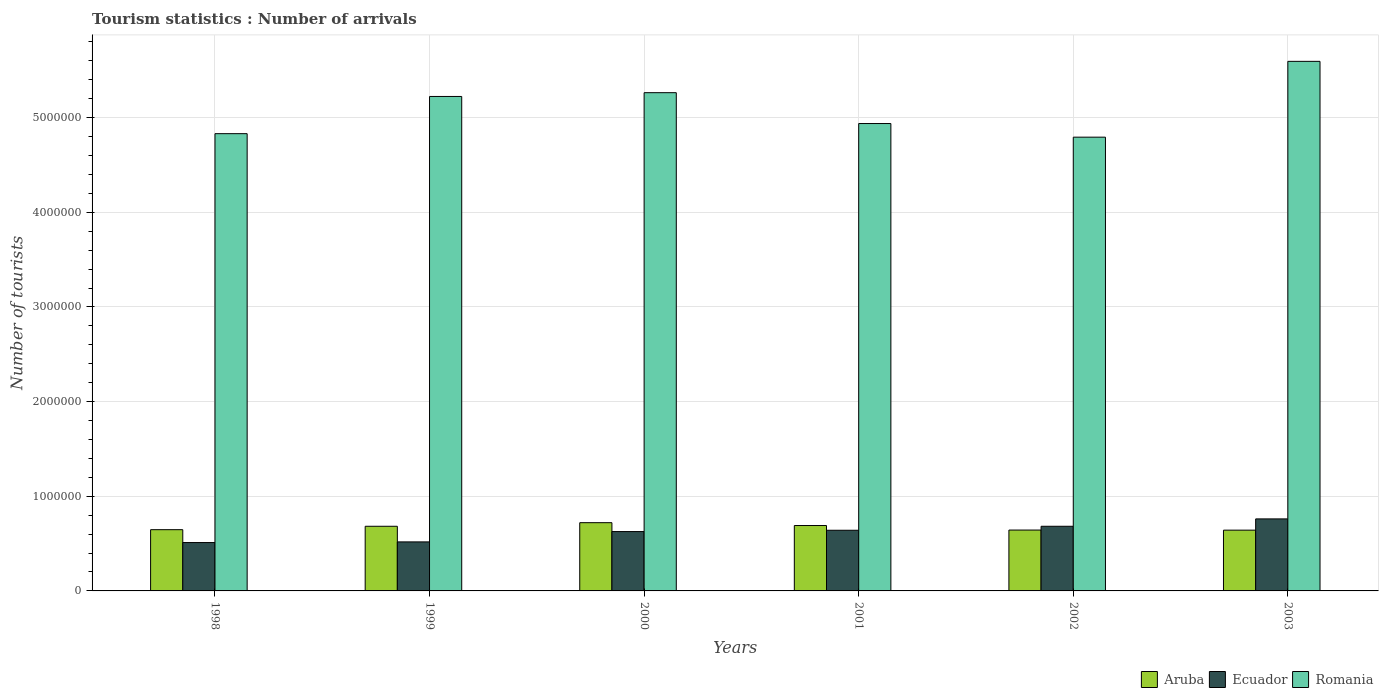Are the number of bars on each tick of the X-axis equal?
Your answer should be compact. Yes. How many bars are there on the 2nd tick from the left?
Provide a succinct answer. 3. How many bars are there on the 3rd tick from the right?
Your response must be concise. 3. What is the label of the 3rd group of bars from the left?
Your answer should be very brief. 2000. What is the number of tourist arrivals in Romania in 2000?
Your answer should be compact. 5.26e+06. Across all years, what is the maximum number of tourist arrivals in Ecuador?
Give a very brief answer. 7.61e+05. Across all years, what is the minimum number of tourist arrivals in Aruba?
Ensure brevity in your answer.  6.42e+05. In which year was the number of tourist arrivals in Romania maximum?
Offer a very short reply. 2003. In which year was the number of tourist arrivals in Romania minimum?
Give a very brief answer. 2002. What is the total number of tourist arrivals in Aruba in the graph?
Your answer should be very brief. 4.03e+06. What is the difference between the number of tourist arrivals in Romania in 2000 and that in 2002?
Keep it short and to the point. 4.70e+05. What is the difference between the number of tourist arrivals in Aruba in 2003 and the number of tourist arrivals in Romania in 2001?
Offer a very short reply. -4.30e+06. What is the average number of tourist arrivals in Ecuador per year?
Give a very brief answer. 6.24e+05. In the year 2000, what is the difference between the number of tourist arrivals in Romania and number of tourist arrivals in Ecuador?
Offer a terse response. 4.64e+06. What is the ratio of the number of tourist arrivals in Romania in 1998 to that in 2000?
Offer a very short reply. 0.92. Is the number of tourist arrivals in Romania in 1999 less than that in 2001?
Your answer should be very brief. No. What is the difference between the highest and the second highest number of tourist arrivals in Romania?
Keep it short and to the point. 3.31e+05. What is the difference between the highest and the lowest number of tourist arrivals in Aruba?
Ensure brevity in your answer.  7.90e+04. What does the 2nd bar from the left in 1998 represents?
Your answer should be very brief. Ecuador. What does the 3rd bar from the right in 2001 represents?
Your answer should be compact. Aruba. Is it the case that in every year, the sum of the number of tourist arrivals in Aruba and number of tourist arrivals in Ecuador is greater than the number of tourist arrivals in Romania?
Provide a succinct answer. No. Are all the bars in the graph horizontal?
Offer a terse response. No. What is the difference between two consecutive major ticks on the Y-axis?
Keep it short and to the point. 1.00e+06. Are the values on the major ticks of Y-axis written in scientific E-notation?
Your answer should be very brief. No. Does the graph contain grids?
Your answer should be compact. Yes. Where does the legend appear in the graph?
Your answer should be compact. Bottom right. How many legend labels are there?
Offer a very short reply. 3. What is the title of the graph?
Make the answer very short. Tourism statistics : Number of arrivals. Does "Botswana" appear as one of the legend labels in the graph?
Make the answer very short. No. What is the label or title of the X-axis?
Your answer should be compact. Years. What is the label or title of the Y-axis?
Your answer should be very brief. Number of tourists. What is the Number of tourists of Aruba in 1998?
Your response must be concise. 6.47e+05. What is the Number of tourists in Ecuador in 1998?
Your response must be concise. 5.11e+05. What is the Number of tourists in Romania in 1998?
Your answer should be very brief. 4.83e+06. What is the Number of tourists in Aruba in 1999?
Your answer should be very brief. 6.83e+05. What is the Number of tourists of Ecuador in 1999?
Offer a very short reply. 5.18e+05. What is the Number of tourists in Romania in 1999?
Make the answer very short. 5.22e+06. What is the Number of tourists of Aruba in 2000?
Make the answer very short. 7.21e+05. What is the Number of tourists of Ecuador in 2000?
Your answer should be compact. 6.27e+05. What is the Number of tourists of Romania in 2000?
Make the answer very short. 5.26e+06. What is the Number of tourists in Aruba in 2001?
Provide a short and direct response. 6.91e+05. What is the Number of tourists in Ecuador in 2001?
Make the answer very short. 6.41e+05. What is the Number of tourists in Romania in 2001?
Your answer should be compact. 4.94e+06. What is the Number of tourists in Aruba in 2002?
Give a very brief answer. 6.43e+05. What is the Number of tourists in Ecuador in 2002?
Your answer should be compact. 6.83e+05. What is the Number of tourists in Romania in 2002?
Your answer should be very brief. 4.79e+06. What is the Number of tourists of Aruba in 2003?
Make the answer very short. 6.42e+05. What is the Number of tourists of Ecuador in 2003?
Offer a terse response. 7.61e+05. What is the Number of tourists of Romania in 2003?
Give a very brief answer. 5.60e+06. Across all years, what is the maximum Number of tourists in Aruba?
Offer a terse response. 7.21e+05. Across all years, what is the maximum Number of tourists of Ecuador?
Offer a terse response. 7.61e+05. Across all years, what is the maximum Number of tourists in Romania?
Make the answer very short. 5.60e+06. Across all years, what is the minimum Number of tourists of Aruba?
Offer a very short reply. 6.42e+05. Across all years, what is the minimum Number of tourists in Ecuador?
Provide a succinct answer. 5.11e+05. Across all years, what is the minimum Number of tourists of Romania?
Your answer should be compact. 4.79e+06. What is the total Number of tourists in Aruba in the graph?
Give a very brief answer. 4.03e+06. What is the total Number of tourists of Ecuador in the graph?
Make the answer very short. 3.74e+06. What is the total Number of tourists of Romania in the graph?
Give a very brief answer. 3.06e+07. What is the difference between the Number of tourists in Aruba in 1998 and that in 1999?
Offer a very short reply. -3.60e+04. What is the difference between the Number of tourists in Ecuador in 1998 and that in 1999?
Keep it short and to the point. -7000. What is the difference between the Number of tourists in Romania in 1998 and that in 1999?
Offer a terse response. -3.93e+05. What is the difference between the Number of tourists of Aruba in 1998 and that in 2000?
Make the answer very short. -7.40e+04. What is the difference between the Number of tourists in Ecuador in 1998 and that in 2000?
Keep it short and to the point. -1.16e+05. What is the difference between the Number of tourists of Romania in 1998 and that in 2000?
Keep it short and to the point. -4.33e+05. What is the difference between the Number of tourists in Aruba in 1998 and that in 2001?
Ensure brevity in your answer.  -4.40e+04. What is the difference between the Number of tourists of Ecuador in 1998 and that in 2001?
Your response must be concise. -1.30e+05. What is the difference between the Number of tourists of Romania in 1998 and that in 2001?
Ensure brevity in your answer.  -1.07e+05. What is the difference between the Number of tourists of Aruba in 1998 and that in 2002?
Keep it short and to the point. 4000. What is the difference between the Number of tourists in Ecuador in 1998 and that in 2002?
Your answer should be very brief. -1.72e+05. What is the difference between the Number of tourists of Romania in 1998 and that in 2002?
Make the answer very short. 3.70e+04. What is the difference between the Number of tourists in Aruba in 1998 and that in 2003?
Make the answer very short. 5000. What is the difference between the Number of tourists of Romania in 1998 and that in 2003?
Provide a short and direct response. -7.64e+05. What is the difference between the Number of tourists in Aruba in 1999 and that in 2000?
Your answer should be compact. -3.80e+04. What is the difference between the Number of tourists in Ecuador in 1999 and that in 2000?
Offer a very short reply. -1.09e+05. What is the difference between the Number of tourists in Romania in 1999 and that in 2000?
Make the answer very short. -4.00e+04. What is the difference between the Number of tourists of Aruba in 1999 and that in 2001?
Provide a succinct answer. -8000. What is the difference between the Number of tourists in Ecuador in 1999 and that in 2001?
Ensure brevity in your answer.  -1.23e+05. What is the difference between the Number of tourists in Romania in 1999 and that in 2001?
Your response must be concise. 2.86e+05. What is the difference between the Number of tourists in Aruba in 1999 and that in 2002?
Give a very brief answer. 4.00e+04. What is the difference between the Number of tourists of Ecuador in 1999 and that in 2002?
Keep it short and to the point. -1.65e+05. What is the difference between the Number of tourists of Aruba in 1999 and that in 2003?
Your answer should be compact. 4.10e+04. What is the difference between the Number of tourists in Ecuador in 1999 and that in 2003?
Offer a very short reply. -2.43e+05. What is the difference between the Number of tourists in Romania in 1999 and that in 2003?
Keep it short and to the point. -3.71e+05. What is the difference between the Number of tourists in Aruba in 2000 and that in 2001?
Keep it short and to the point. 3.00e+04. What is the difference between the Number of tourists of Ecuador in 2000 and that in 2001?
Give a very brief answer. -1.40e+04. What is the difference between the Number of tourists in Romania in 2000 and that in 2001?
Give a very brief answer. 3.26e+05. What is the difference between the Number of tourists of Aruba in 2000 and that in 2002?
Keep it short and to the point. 7.80e+04. What is the difference between the Number of tourists in Ecuador in 2000 and that in 2002?
Provide a short and direct response. -5.60e+04. What is the difference between the Number of tourists in Aruba in 2000 and that in 2003?
Offer a very short reply. 7.90e+04. What is the difference between the Number of tourists of Ecuador in 2000 and that in 2003?
Your response must be concise. -1.34e+05. What is the difference between the Number of tourists in Romania in 2000 and that in 2003?
Your answer should be very brief. -3.31e+05. What is the difference between the Number of tourists in Aruba in 2001 and that in 2002?
Give a very brief answer. 4.80e+04. What is the difference between the Number of tourists of Ecuador in 2001 and that in 2002?
Your answer should be very brief. -4.20e+04. What is the difference between the Number of tourists of Romania in 2001 and that in 2002?
Your answer should be compact. 1.44e+05. What is the difference between the Number of tourists in Aruba in 2001 and that in 2003?
Give a very brief answer. 4.90e+04. What is the difference between the Number of tourists in Ecuador in 2001 and that in 2003?
Give a very brief answer. -1.20e+05. What is the difference between the Number of tourists of Romania in 2001 and that in 2003?
Give a very brief answer. -6.57e+05. What is the difference between the Number of tourists of Aruba in 2002 and that in 2003?
Your answer should be very brief. 1000. What is the difference between the Number of tourists of Ecuador in 2002 and that in 2003?
Provide a short and direct response. -7.80e+04. What is the difference between the Number of tourists of Romania in 2002 and that in 2003?
Offer a terse response. -8.01e+05. What is the difference between the Number of tourists of Aruba in 1998 and the Number of tourists of Ecuador in 1999?
Provide a short and direct response. 1.29e+05. What is the difference between the Number of tourists in Aruba in 1998 and the Number of tourists in Romania in 1999?
Offer a very short reply. -4.58e+06. What is the difference between the Number of tourists in Ecuador in 1998 and the Number of tourists in Romania in 1999?
Ensure brevity in your answer.  -4.71e+06. What is the difference between the Number of tourists of Aruba in 1998 and the Number of tourists of Romania in 2000?
Your response must be concise. -4.62e+06. What is the difference between the Number of tourists in Ecuador in 1998 and the Number of tourists in Romania in 2000?
Ensure brevity in your answer.  -4.75e+06. What is the difference between the Number of tourists in Aruba in 1998 and the Number of tourists in Ecuador in 2001?
Offer a very short reply. 6000. What is the difference between the Number of tourists in Aruba in 1998 and the Number of tourists in Romania in 2001?
Ensure brevity in your answer.  -4.29e+06. What is the difference between the Number of tourists of Ecuador in 1998 and the Number of tourists of Romania in 2001?
Make the answer very short. -4.43e+06. What is the difference between the Number of tourists of Aruba in 1998 and the Number of tourists of Ecuador in 2002?
Give a very brief answer. -3.60e+04. What is the difference between the Number of tourists of Aruba in 1998 and the Number of tourists of Romania in 2002?
Make the answer very short. -4.15e+06. What is the difference between the Number of tourists in Ecuador in 1998 and the Number of tourists in Romania in 2002?
Make the answer very short. -4.28e+06. What is the difference between the Number of tourists in Aruba in 1998 and the Number of tourists in Ecuador in 2003?
Provide a short and direct response. -1.14e+05. What is the difference between the Number of tourists in Aruba in 1998 and the Number of tourists in Romania in 2003?
Give a very brief answer. -4.95e+06. What is the difference between the Number of tourists in Ecuador in 1998 and the Number of tourists in Romania in 2003?
Offer a very short reply. -5.08e+06. What is the difference between the Number of tourists of Aruba in 1999 and the Number of tourists of Ecuador in 2000?
Ensure brevity in your answer.  5.60e+04. What is the difference between the Number of tourists in Aruba in 1999 and the Number of tourists in Romania in 2000?
Provide a short and direct response. -4.58e+06. What is the difference between the Number of tourists in Ecuador in 1999 and the Number of tourists in Romania in 2000?
Ensure brevity in your answer.  -4.75e+06. What is the difference between the Number of tourists in Aruba in 1999 and the Number of tourists in Ecuador in 2001?
Provide a short and direct response. 4.20e+04. What is the difference between the Number of tourists of Aruba in 1999 and the Number of tourists of Romania in 2001?
Make the answer very short. -4.26e+06. What is the difference between the Number of tourists of Ecuador in 1999 and the Number of tourists of Romania in 2001?
Your response must be concise. -4.42e+06. What is the difference between the Number of tourists of Aruba in 1999 and the Number of tourists of Romania in 2002?
Keep it short and to the point. -4.11e+06. What is the difference between the Number of tourists of Ecuador in 1999 and the Number of tourists of Romania in 2002?
Offer a terse response. -4.28e+06. What is the difference between the Number of tourists in Aruba in 1999 and the Number of tourists in Ecuador in 2003?
Offer a terse response. -7.80e+04. What is the difference between the Number of tourists of Aruba in 1999 and the Number of tourists of Romania in 2003?
Provide a succinct answer. -4.91e+06. What is the difference between the Number of tourists in Ecuador in 1999 and the Number of tourists in Romania in 2003?
Give a very brief answer. -5.08e+06. What is the difference between the Number of tourists of Aruba in 2000 and the Number of tourists of Ecuador in 2001?
Your answer should be very brief. 8.00e+04. What is the difference between the Number of tourists in Aruba in 2000 and the Number of tourists in Romania in 2001?
Offer a terse response. -4.22e+06. What is the difference between the Number of tourists of Ecuador in 2000 and the Number of tourists of Romania in 2001?
Make the answer very short. -4.31e+06. What is the difference between the Number of tourists of Aruba in 2000 and the Number of tourists of Ecuador in 2002?
Offer a very short reply. 3.80e+04. What is the difference between the Number of tourists of Aruba in 2000 and the Number of tourists of Romania in 2002?
Your answer should be very brief. -4.07e+06. What is the difference between the Number of tourists in Ecuador in 2000 and the Number of tourists in Romania in 2002?
Provide a short and direct response. -4.17e+06. What is the difference between the Number of tourists of Aruba in 2000 and the Number of tourists of Ecuador in 2003?
Ensure brevity in your answer.  -4.00e+04. What is the difference between the Number of tourists of Aruba in 2000 and the Number of tourists of Romania in 2003?
Your answer should be very brief. -4.87e+06. What is the difference between the Number of tourists in Ecuador in 2000 and the Number of tourists in Romania in 2003?
Give a very brief answer. -4.97e+06. What is the difference between the Number of tourists in Aruba in 2001 and the Number of tourists in Ecuador in 2002?
Provide a short and direct response. 8000. What is the difference between the Number of tourists in Aruba in 2001 and the Number of tourists in Romania in 2002?
Keep it short and to the point. -4.10e+06. What is the difference between the Number of tourists of Ecuador in 2001 and the Number of tourists of Romania in 2002?
Offer a very short reply. -4.15e+06. What is the difference between the Number of tourists of Aruba in 2001 and the Number of tourists of Romania in 2003?
Make the answer very short. -4.90e+06. What is the difference between the Number of tourists of Ecuador in 2001 and the Number of tourists of Romania in 2003?
Keep it short and to the point. -4.95e+06. What is the difference between the Number of tourists of Aruba in 2002 and the Number of tourists of Ecuador in 2003?
Offer a very short reply. -1.18e+05. What is the difference between the Number of tourists of Aruba in 2002 and the Number of tourists of Romania in 2003?
Keep it short and to the point. -4.95e+06. What is the difference between the Number of tourists of Ecuador in 2002 and the Number of tourists of Romania in 2003?
Ensure brevity in your answer.  -4.91e+06. What is the average Number of tourists in Aruba per year?
Ensure brevity in your answer.  6.71e+05. What is the average Number of tourists in Ecuador per year?
Make the answer very short. 6.24e+05. What is the average Number of tourists of Romania per year?
Offer a very short reply. 5.11e+06. In the year 1998, what is the difference between the Number of tourists in Aruba and Number of tourists in Ecuador?
Your response must be concise. 1.36e+05. In the year 1998, what is the difference between the Number of tourists of Aruba and Number of tourists of Romania?
Offer a very short reply. -4.18e+06. In the year 1998, what is the difference between the Number of tourists in Ecuador and Number of tourists in Romania?
Offer a very short reply. -4.32e+06. In the year 1999, what is the difference between the Number of tourists of Aruba and Number of tourists of Ecuador?
Provide a succinct answer. 1.65e+05. In the year 1999, what is the difference between the Number of tourists of Aruba and Number of tourists of Romania?
Your response must be concise. -4.54e+06. In the year 1999, what is the difference between the Number of tourists of Ecuador and Number of tourists of Romania?
Ensure brevity in your answer.  -4.71e+06. In the year 2000, what is the difference between the Number of tourists of Aruba and Number of tourists of Ecuador?
Give a very brief answer. 9.40e+04. In the year 2000, what is the difference between the Number of tourists of Aruba and Number of tourists of Romania?
Offer a very short reply. -4.54e+06. In the year 2000, what is the difference between the Number of tourists in Ecuador and Number of tourists in Romania?
Offer a very short reply. -4.64e+06. In the year 2001, what is the difference between the Number of tourists of Aruba and Number of tourists of Ecuador?
Provide a short and direct response. 5.00e+04. In the year 2001, what is the difference between the Number of tourists of Aruba and Number of tourists of Romania?
Offer a very short reply. -4.25e+06. In the year 2001, what is the difference between the Number of tourists of Ecuador and Number of tourists of Romania?
Make the answer very short. -4.30e+06. In the year 2002, what is the difference between the Number of tourists in Aruba and Number of tourists in Romania?
Provide a succinct answer. -4.15e+06. In the year 2002, what is the difference between the Number of tourists of Ecuador and Number of tourists of Romania?
Ensure brevity in your answer.  -4.11e+06. In the year 2003, what is the difference between the Number of tourists of Aruba and Number of tourists of Ecuador?
Offer a terse response. -1.19e+05. In the year 2003, what is the difference between the Number of tourists of Aruba and Number of tourists of Romania?
Offer a very short reply. -4.95e+06. In the year 2003, what is the difference between the Number of tourists in Ecuador and Number of tourists in Romania?
Offer a very short reply. -4.83e+06. What is the ratio of the Number of tourists in Aruba in 1998 to that in 1999?
Ensure brevity in your answer.  0.95. What is the ratio of the Number of tourists of Ecuador in 1998 to that in 1999?
Offer a very short reply. 0.99. What is the ratio of the Number of tourists in Romania in 1998 to that in 1999?
Offer a terse response. 0.92. What is the ratio of the Number of tourists of Aruba in 1998 to that in 2000?
Your response must be concise. 0.9. What is the ratio of the Number of tourists of Ecuador in 1998 to that in 2000?
Make the answer very short. 0.81. What is the ratio of the Number of tourists in Romania in 1998 to that in 2000?
Your answer should be very brief. 0.92. What is the ratio of the Number of tourists of Aruba in 1998 to that in 2001?
Give a very brief answer. 0.94. What is the ratio of the Number of tourists in Ecuador in 1998 to that in 2001?
Offer a terse response. 0.8. What is the ratio of the Number of tourists of Romania in 1998 to that in 2001?
Give a very brief answer. 0.98. What is the ratio of the Number of tourists of Aruba in 1998 to that in 2002?
Make the answer very short. 1.01. What is the ratio of the Number of tourists of Ecuador in 1998 to that in 2002?
Your response must be concise. 0.75. What is the ratio of the Number of tourists of Romania in 1998 to that in 2002?
Offer a terse response. 1.01. What is the ratio of the Number of tourists in Ecuador in 1998 to that in 2003?
Provide a short and direct response. 0.67. What is the ratio of the Number of tourists of Romania in 1998 to that in 2003?
Keep it short and to the point. 0.86. What is the ratio of the Number of tourists of Aruba in 1999 to that in 2000?
Your response must be concise. 0.95. What is the ratio of the Number of tourists of Ecuador in 1999 to that in 2000?
Your answer should be compact. 0.83. What is the ratio of the Number of tourists in Aruba in 1999 to that in 2001?
Offer a terse response. 0.99. What is the ratio of the Number of tourists of Ecuador in 1999 to that in 2001?
Provide a succinct answer. 0.81. What is the ratio of the Number of tourists of Romania in 1999 to that in 2001?
Keep it short and to the point. 1.06. What is the ratio of the Number of tourists of Aruba in 1999 to that in 2002?
Ensure brevity in your answer.  1.06. What is the ratio of the Number of tourists in Ecuador in 1999 to that in 2002?
Give a very brief answer. 0.76. What is the ratio of the Number of tourists in Romania in 1999 to that in 2002?
Your answer should be compact. 1.09. What is the ratio of the Number of tourists of Aruba in 1999 to that in 2003?
Your answer should be very brief. 1.06. What is the ratio of the Number of tourists of Ecuador in 1999 to that in 2003?
Keep it short and to the point. 0.68. What is the ratio of the Number of tourists of Romania in 1999 to that in 2003?
Provide a succinct answer. 0.93. What is the ratio of the Number of tourists in Aruba in 2000 to that in 2001?
Your response must be concise. 1.04. What is the ratio of the Number of tourists in Ecuador in 2000 to that in 2001?
Provide a short and direct response. 0.98. What is the ratio of the Number of tourists of Romania in 2000 to that in 2001?
Provide a succinct answer. 1.07. What is the ratio of the Number of tourists in Aruba in 2000 to that in 2002?
Your answer should be very brief. 1.12. What is the ratio of the Number of tourists of Ecuador in 2000 to that in 2002?
Give a very brief answer. 0.92. What is the ratio of the Number of tourists of Romania in 2000 to that in 2002?
Ensure brevity in your answer.  1.1. What is the ratio of the Number of tourists in Aruba in 2000 to that in 2003?
Your answer should be very brief. 1.12. What is the ratio of the Number of tourists in Ecuador in 2000 to that in 2003?
Provide a short and direct response. 0.82. What is the ratio of the Number of tourists of Romania in 2000 to that in 2003?
Provide a succinct answer. 0.94. What is the ratio of the Number of tourists of Aruba in 2001 to that in 2002?
Your answer should be compact. 1.07. What is the ratio of the Number of tourists of Ecuador in 2001 to that in 2002?
Give a very brief answer. 0.94. What is the ratio of the Number of tourists of Aruba in 2001 to that in 2003?
Your answer should be compact. 1.08. What is the ratio of the Number of tourists of Ecuador in 2001 to that in 2003?
Offer a very short reply. 0.84. What is the ratio of the Number of tourists of Romania in 2001 to that in 2003?
Provide a short and direct response. 0.88. What is the ratio of the Number of tourists of Aruba in 2002 to that in 2003?
Your answer should be compact. 1. What is the ratio of the Number of tourists of Ecuador in 2002 to that in 2003?
Your response must be concise. 0.9. What is the ratio of the Number of tourists in Romania in 2002 to that in 2003?
Ensure brevity in your answer.  0.86. What is the difference between the highest and the second highest Number of tourists in Ecuador?
Your answer should be compact. 7.80e+04. What is the difference between the highest and the second highest Number of tourists of Romania?
Offer a very short reply. 3.31e+05. What is the difference between the highest and the lowest Number of tourists in Aruba?
Your answer should be compact. 7.90e+04. What is the difference between the highest and the lowest Number of tourists in Romania?
Provide a succinct answer. 8.01e+05. 